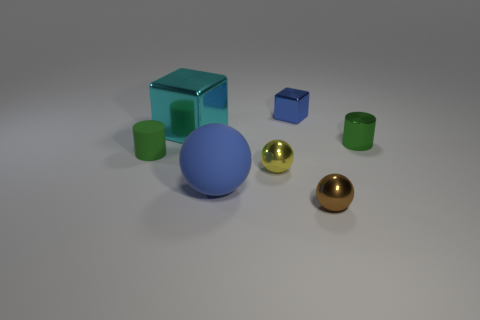Add 3 big shiny cubes. How many objects exist? 10 Subtract all cylinders. How many objects are left? 5 Subtract 1 brown balls. How many objects are left? 6 Subtract all tiny balls. Subtract all green matte cylinders. How many objects are left? 4 Add 1 small brown shiny spheres. How many small brown shiny spheres are left? 2 Add 5 green metal things. How many green metal things exist? 6 